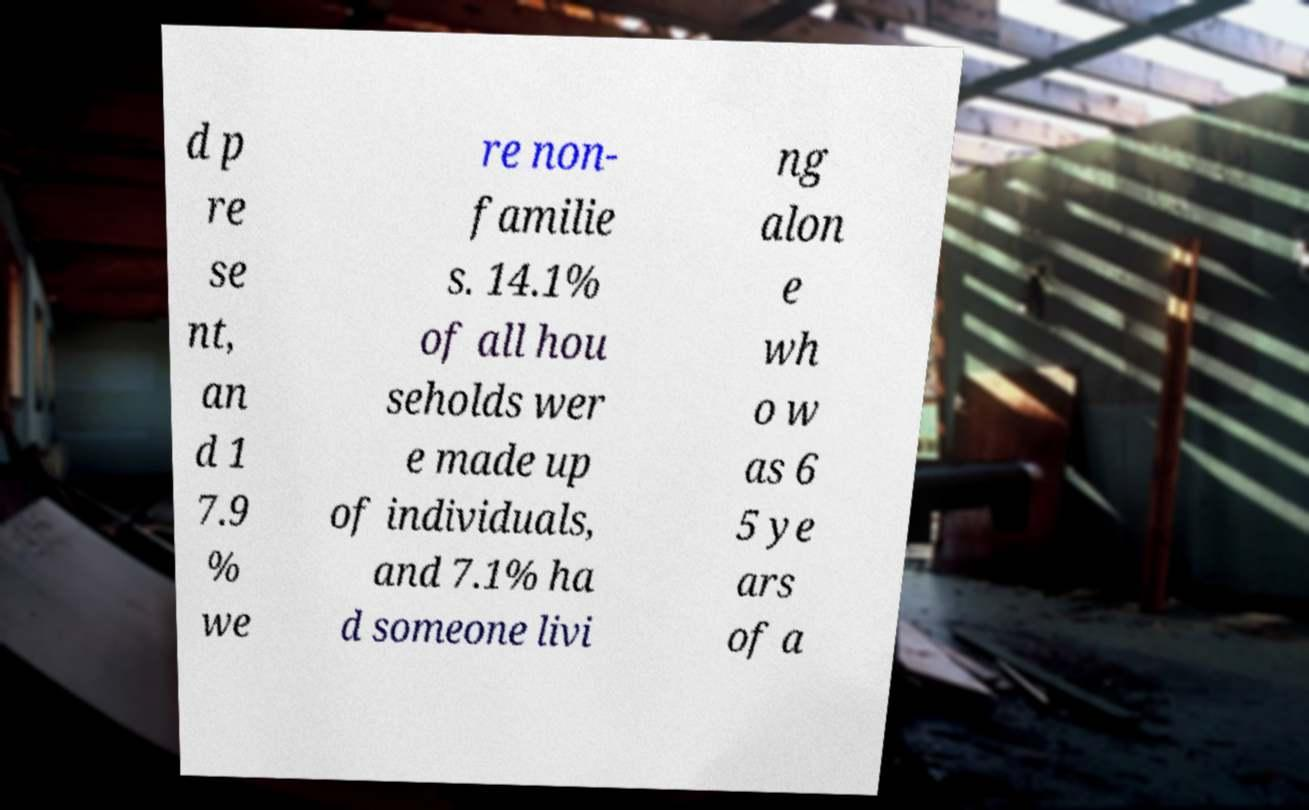Please read and relay the text visible in this image. What does it say? d p re se nt, an d 1 7.9 % we re non- familie s. 14.1% of all hou seholds wer e made up of individuals, and 7.1% ha d someone livi ng alon e wh o w as 6 5 ye ars of a 